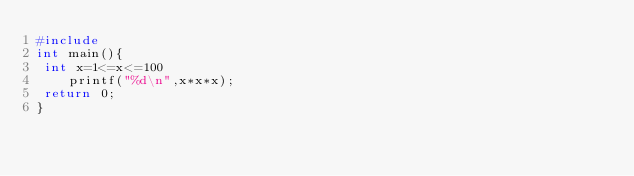<code> <loc_0><loc_0><loc_500><loc_500><_C_>#include
int main(){
 int x=1<=x<=100
    printf("%d\n",x*x*x);
 return 0;
}
</code> 